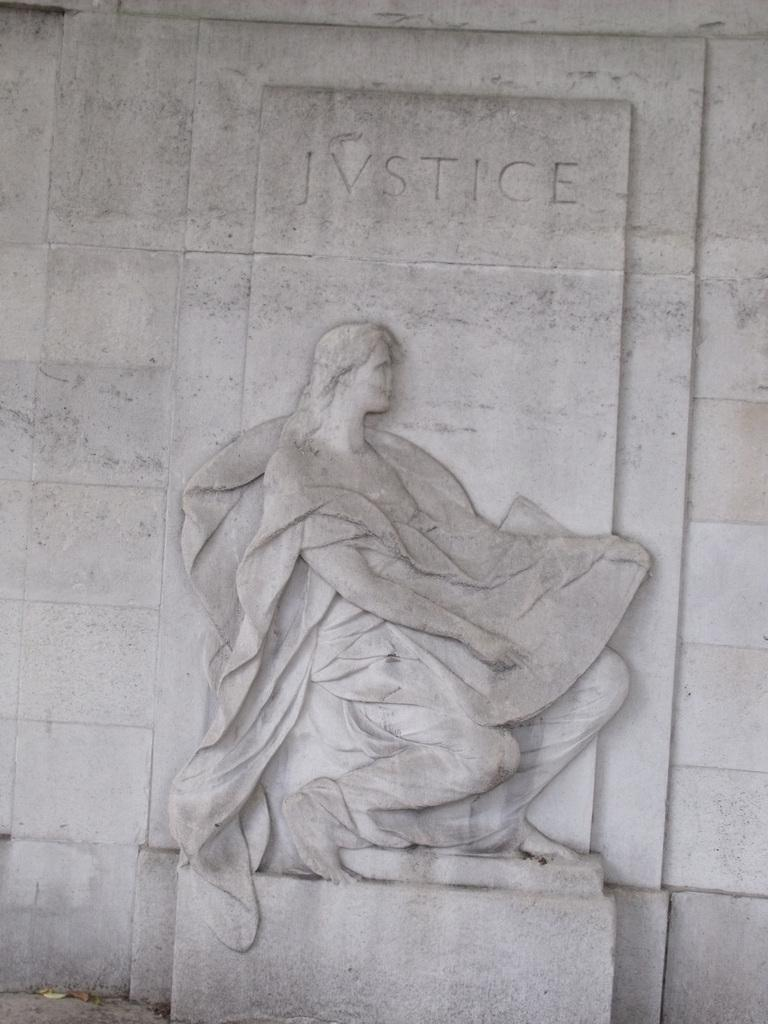What is depicted on the wall in the image? There is a stone carving on a wall in the image. Can you describe the stone carving in more detail? Unfortunately, the details of the stone carving cannot be discerned from the image alone. What type of material is the wall made of? The wall is made of stone, as indicated by the stone carving on it. What type of treatment is being administered to the river in the image? There is no river present in the image, and therefore no treatment is being administered. How does the stone carving make you feel when looking at the image? The image does not convey any feelings or emotions, as it is a static representation of a stone carving on a wall. 